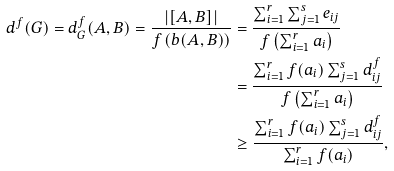Convert formula to latex. <formula><loc_0><loc_0><loc_500><loc_500>d ^ { f } ( G ) = d ^ { f } _ { G } ( A , B ) = \frac { | [ A , B ] | } { f \left ( b ( A , B ) \right ) } & = \frac { \sum _ { i = 1 } ^ { r } \sum _ { j = 1 } ^ { s } e _ { i j } } { f \left ( \sum _ { i = 1 } ^ { r } a _ { i } \right ) } \\ & = \frac { \sum _ { i = 1 } ^ { r } f ( a _ { i } ) \sum _ { j = 1 } ^ { s } d ^ { f } _ { i j } } { f \left ( \sum _ { i = 1 } ^ { r } a _ { i } \right ) } \\ & \geq \frac { \sum _ { i = 1 } ^ { r } f ( a _ { i } ) \sum _ { j = 1 } ^ { s } d ^ { f } _ { i j } } { \sum _ { i = 1 } ^ { r } f ( a _ { i } ) } ,</formula> 